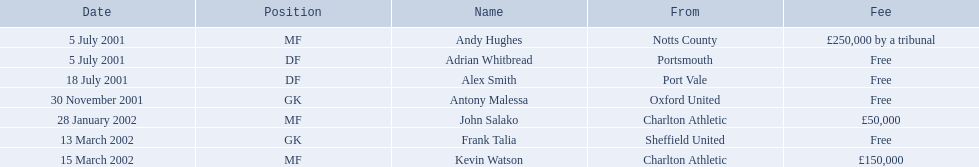Can you provide the names of every player? Andy Hughes, Adrian Whitbread, Alex Smith, Antony Malessa, John Salako, Frank Talia, Kevin Watson. What amount was andy hughes' fee? £250,000 by a tribunal. What was the cost for john salako? £50,000. Who had a greater fee between andy hughes and john salako? Andy Hughes. Parse the full table. {'header': ['Date', 'Position', 'Name', 'From', 'Fee'], 'rows': [['5 July 2001', 'MF', 'Andy Hughes', 'Notts County', '£250,000 by a tribunal'], ['5 July 2001', 'DF', 'Adrian Whitbread', 'Portsmouth', 'Free'], ['18 July 2001', 'DF', 'Alex Smith', 'Port Vale', 'Free'], ['30 November 2001', 'GK', 'Antony Malessa', 'Oxford United', 'Free'], ['28 January 2002', 'MF', 'John Salako', 'Charlton Athletic', '£50,000'], ['13 March 2002', 'GK', 'Frank Talia', 'Sheffield United', 'Free'], ['15 March 2002', 'MF', 'Kevin Watson', 'Charlton Athletic', '£150,000']]} Can you list all the player names? Andy Hughes, Adrian Whitbread, Alex Smith, Antony Malessa, John Salako, Frank Talia, Kevin Watson. What was the fee for andy hughes? £250,000 by a tribunal. What was the fee for john salako? £50,000. Who had a higher fee: andy hughes or john salako? Andy Hughes. Which individuals were involved as players? Andy Hughes, Adrian Whitbread, Alex Smith, Antony Malessa, John Salako, Frank Talia, Kevin Watson. What did each of them pay as fees? £250,000 by a tribunal, Free, Free, Free, £50,000, Free, £150,000. How much did kevin watson contribute as his fee? £150,000. 